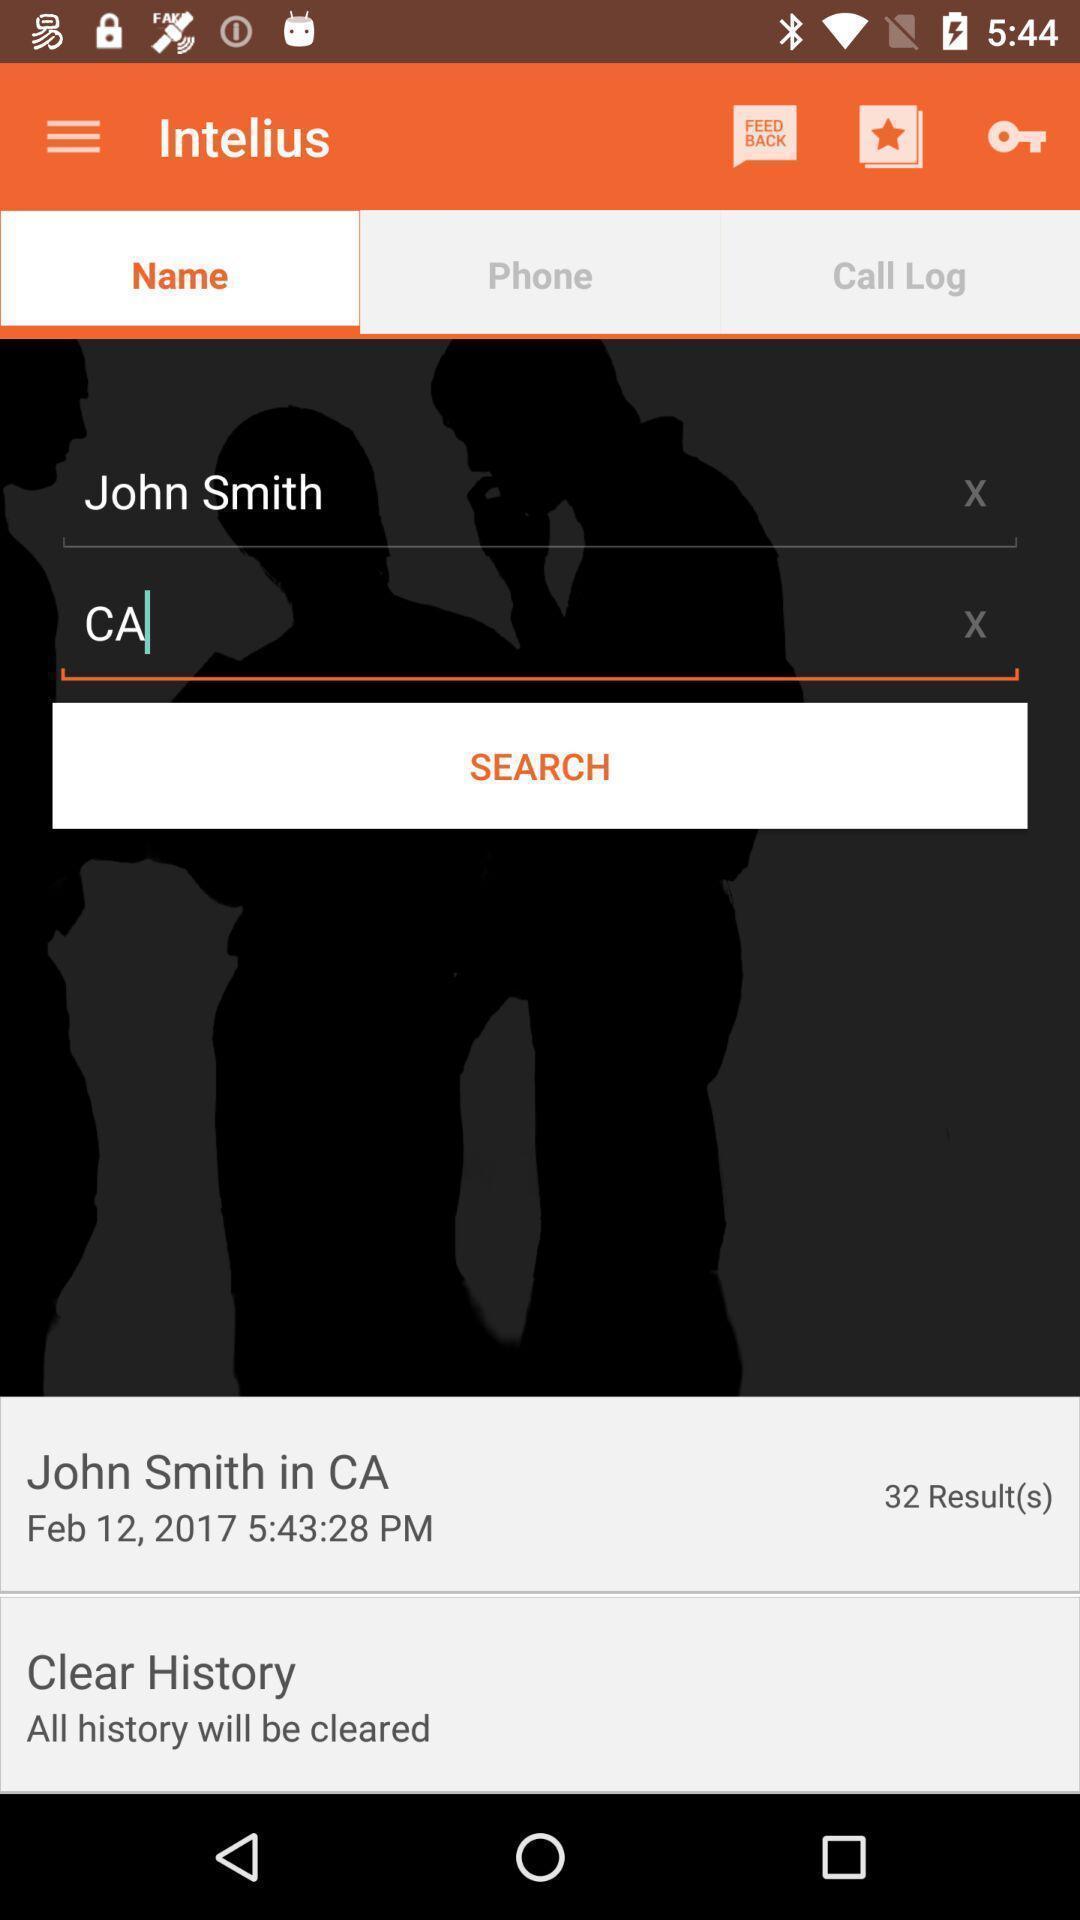Describe the key features of this screenshot. Search bar of a calling application. 